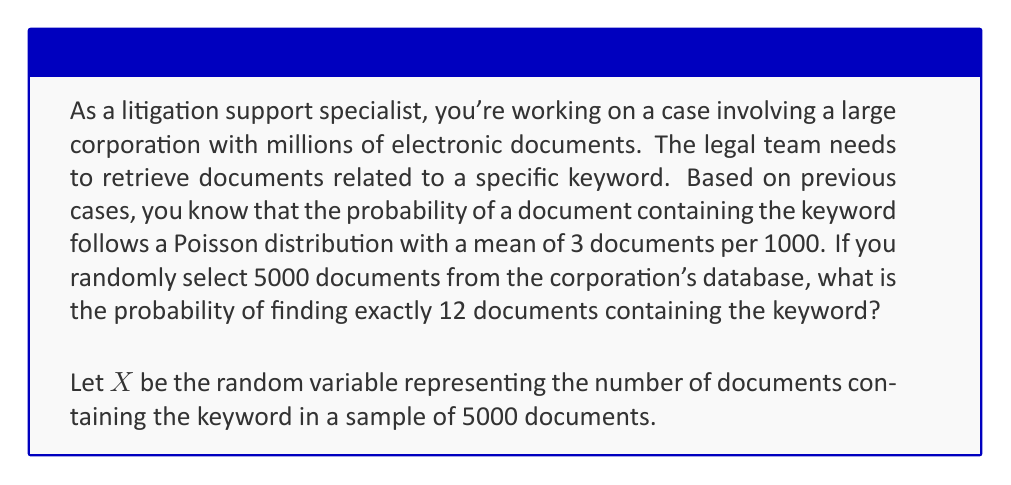Can you solve this math problem? To solve this problem, we'll follow these steps:

1) First, we need to determine the mean (λ) of the Poisson distribution for 5000 documents:
   
   λ = (3 documents / 1000 documents) * 5000 documents = 15

2) Now that we have λ, we can use the Poisson probability mass function:

   $$P(X = k) = \frac{e^{-λ} λ^k}{k!}$$

   Where:
   - e is Euler's number (approximately 2.71828)
   - λ is the mean (15 in this case)
   - k is the number of occurrences we're interested in (12 in this case)

3) Let's substitute our values:

   $$P(X = 12) = \frac{e^{-15} 15^{12}}{12!}$$

4) Now we can calculate:

   $$P(X = 12) = \frac{2.71828^{-15} * 15^{12}}{479001600}$$

5) Using a calculator or computer:

   $$P(X = 12) ≈ 0.0805 \text{ or } 8.05\%$$

Thus, the probability of finding exactly 12 documents containing the keyword in a random sample of 5000 documents is approximately 0.0805 or 8.05%.
Answer: 0.0805 (or 8.05%) 